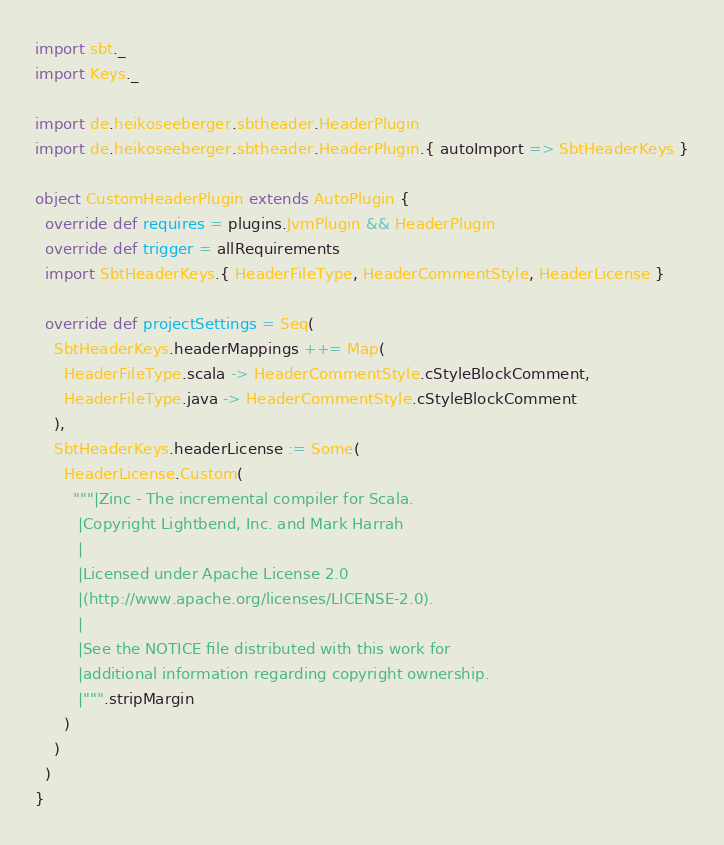<code> <loc_0><loc_0><loc_500><loc_500><_Scala_>import sbt._
import Keys._

import de.heikoseeberger.sbtheader.HeaderPlugin
import de.heikoseeberger.sbtheader.HeaderPlugin.{ autoImport => SbtHeaderKeys }

object CustomHeaderPlugin extends AutoPlugin {
  override def requires = plugins.JvmPlugin && HeaderPlugin
  override def trigger = allRequirements
  import SbtHeaderKeys.{ HeaderFileType, HeaderCommentStyle, HeaderLicense }

  override def projectSettings = Seq(
    SbtHeaderKeys.headerMappings ++= Map(
      HeaderFileType.scala -> HeaderCommentStyle.cStyleBlockComment,
      HeaderFileType.java -> HeaderCommentStyle.cStyleBlockComment
    ),
    SbtHeaderKeys.headerLicense := Some(
      HeaderLicense.Custom(
        """|Zinc - The incremental compiler for Scala.
         |Copyright Lightbend, Inc. and Mark Harrah
         |
         |Licensed under Apache License 2.0
         |(http://www.apache.org/licenses/LICENSE-2.0).
         |
         |See the NOTICE file distributed with this work for
         |additional information regarding copyright ownership.
         |""".stripMargin
      )
    )
  )
}
</code> 